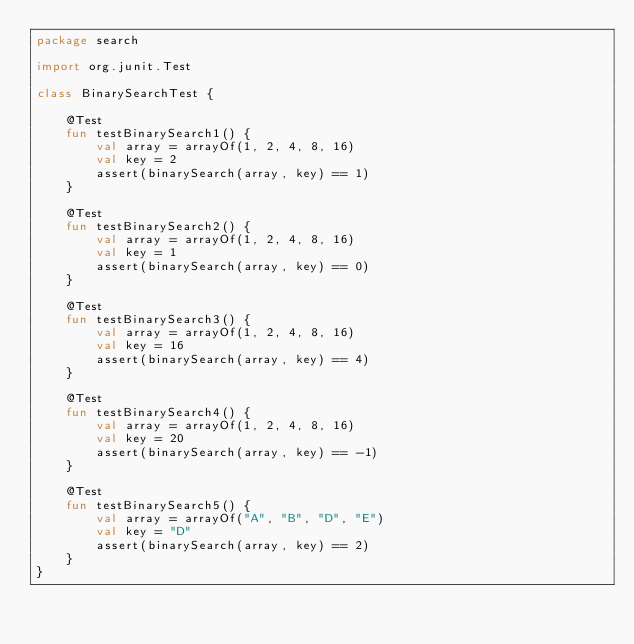Convert code to text. <code><loc_0><loc_0><loc_500><loc_500><_Kotlin_>package search

import org.junit.Test

class BinarySearchTest {

    @Test
    fun testBinarySearch1() {
        val array = arrayOf(1, 2, 4, 8, 16)
        val key = 2
        assert(binarySearch(array, key) == 1)
    }

    @Test
    fun testBinarySearch2() {
        val array = arrayOf(1, 2, 4, 8, 16)
        val key = 1
        assert(binarySearch(array, key) == 0)
    }

    @Test
    fun testBinarySearch3() {
        val array = arrayOf(1, 2, 4, 8, 16)
        val key = 16
        assert(binarySearch(array, key) == 4)
    }

    @Test
    fun testBinarySearch4() {
        val array = arrayOf(1, 2, 4, 8, 16)
        val key = 20
        assert(binarySearch(array, key) == -1)
    }

    @Test
    fun testBinarySearch5() {
        val array = arrayOf("A", "B", "D", "E")
        val key = "D"
        assert(binarySearch(array, key) == 2)
    }
}
</code> 